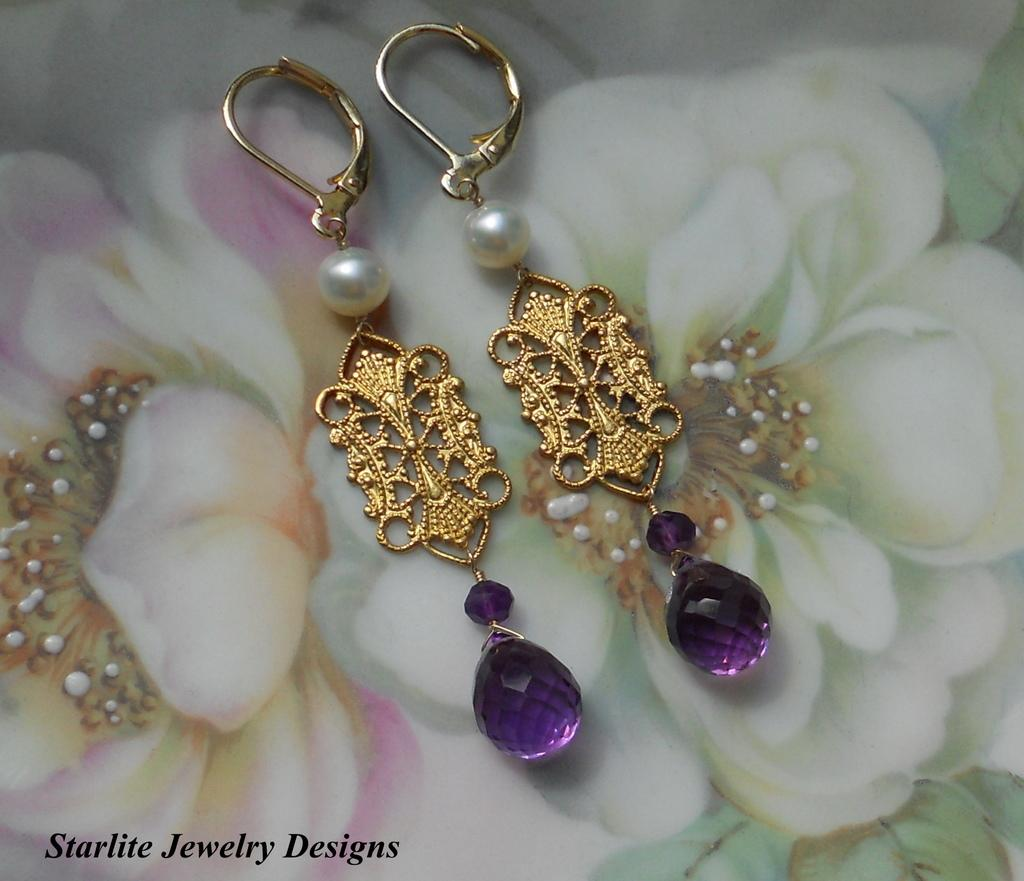What type of accessory is visible in the image? There are earrings in the image. What decorative elements can be seen on the platform in the image? There are pictures of flowers on a platform in the image. What is located at the bottom of the image? There is text at the bottom of the image. What type of quilt is being used to support the earrings in the image? There is no quilt present in the image; the earrings are not supported by a quilt. How does the muscle contribute to the overall design of the earrings in the image? There is no mention of a muscle in the image, and the earrings do not have any muscle-related design elements. 